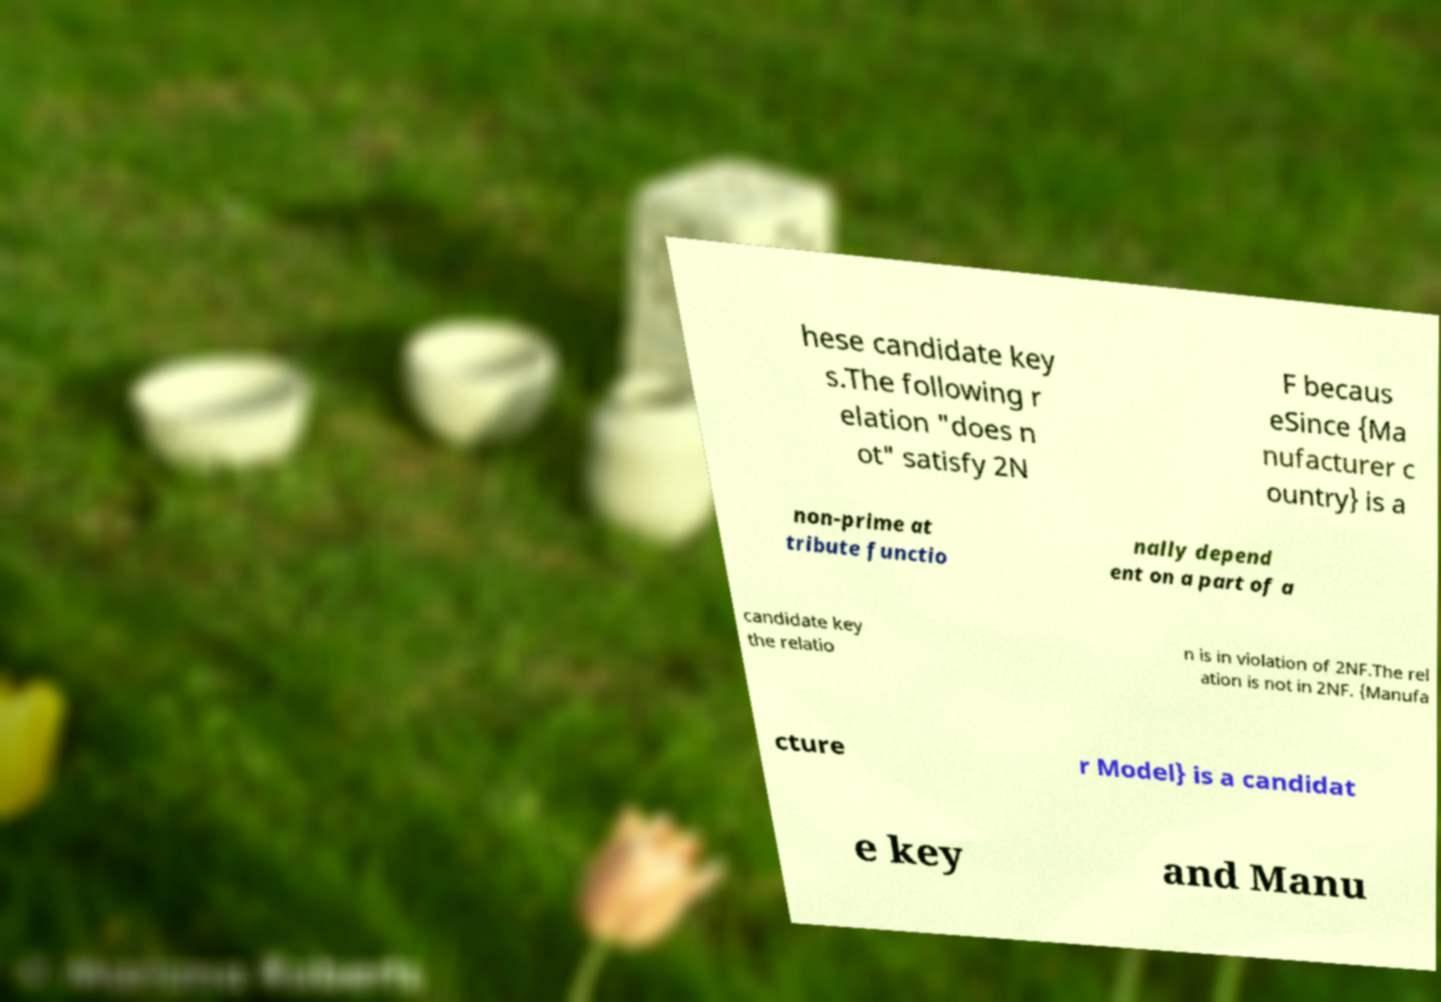Could you assist in decoding the text presented in this image and type it out clearly? hese candidate key s.The following r elation "does n ot" satisfy 2N F becaus eSince {Ma nufacturer c ountry} is a non-prime at tribute functio nally depend ent on a part of a candidate key the relatio n is in violation of 2NF.The rel ation is not in 2NF. {Manufa cture r Model} is a candidat e key and Manu 